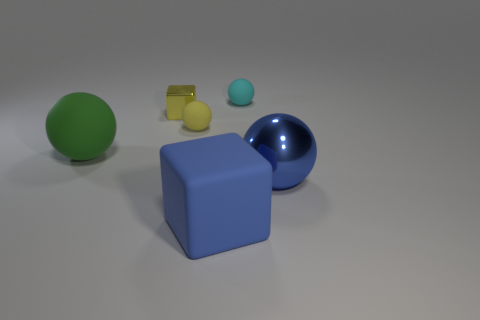How many yellow rubber balls have the same size as the blue matte cube?
Make the answer very short. 0. Are the small ball right of the yellow matte thing and the large thing that is right of the cyan matte ball made of the same material?
Make the answer very short. No. What material is the big sphere that is in front of the rubber object that is left of the yellow shiny cube made of?
Give a very brief answer. Metal. What material is the blue object behind the big blue block?
Offer a very short reply. Metal. What number of other yellow metal objects are the same shape as the yellow shiny thing?
Make the answer very short. 0. Do the metallic ball and the small metallic thing have the same color?
Offer a very short reply. No. There is a blue object that is left of the large sphere right of the matte thing left of the yellow rubber ball; what is it made of?
Make the answer very short. Rubber. Are there any metal cubes in front of the yellow matte object?
Your answer should be compact. No. There is a cyan rubber thing that is the same size as the shiny block; what shape is it?
Offer a very short reply. Sphere. Is the material of the large blue cube the same as the small cyan object?
Ensure brevity in your answer.  Yes. 